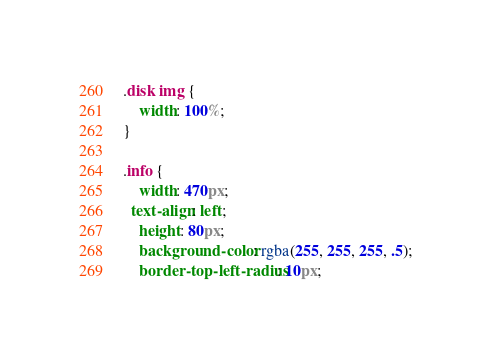Convert code to text. <code><loc_0><loc_0><loc_500><loc_500><_CSS_>
.disk img {
	width: 100%;
}

.info {
	width: 470px;
  text-align: left;
	height: 80px;
	background-color: rgba(255, 255, 255, .5);
	border-top-left-radius: 10px;</code> 